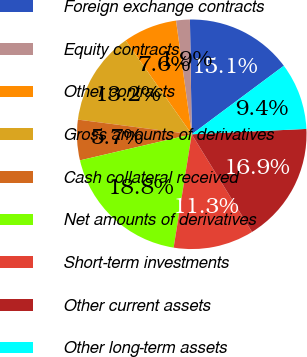Convert chart. <chart><loc_0><loc_0><loc_500><loc_500><pie_chart><fcel>Foreign exchange contracts<fcel>Equity contracts<fcel>Other contracts<fcel>Gross amounts of derivatives<fcel>Cash collateral received<fcel>Net amounts of derivatives<fcel>Short-term investments<fcel>Other current assets<fcel>Other long-term assets<nl><fcel>15.07%<fcel>1.94%<fcel>7.57%<fcel>13.2%<fcel>5.69%<fcel>18.83%<fcel>11.32%<fcel>16.95%<fcel>9.44%<nl></chart> 